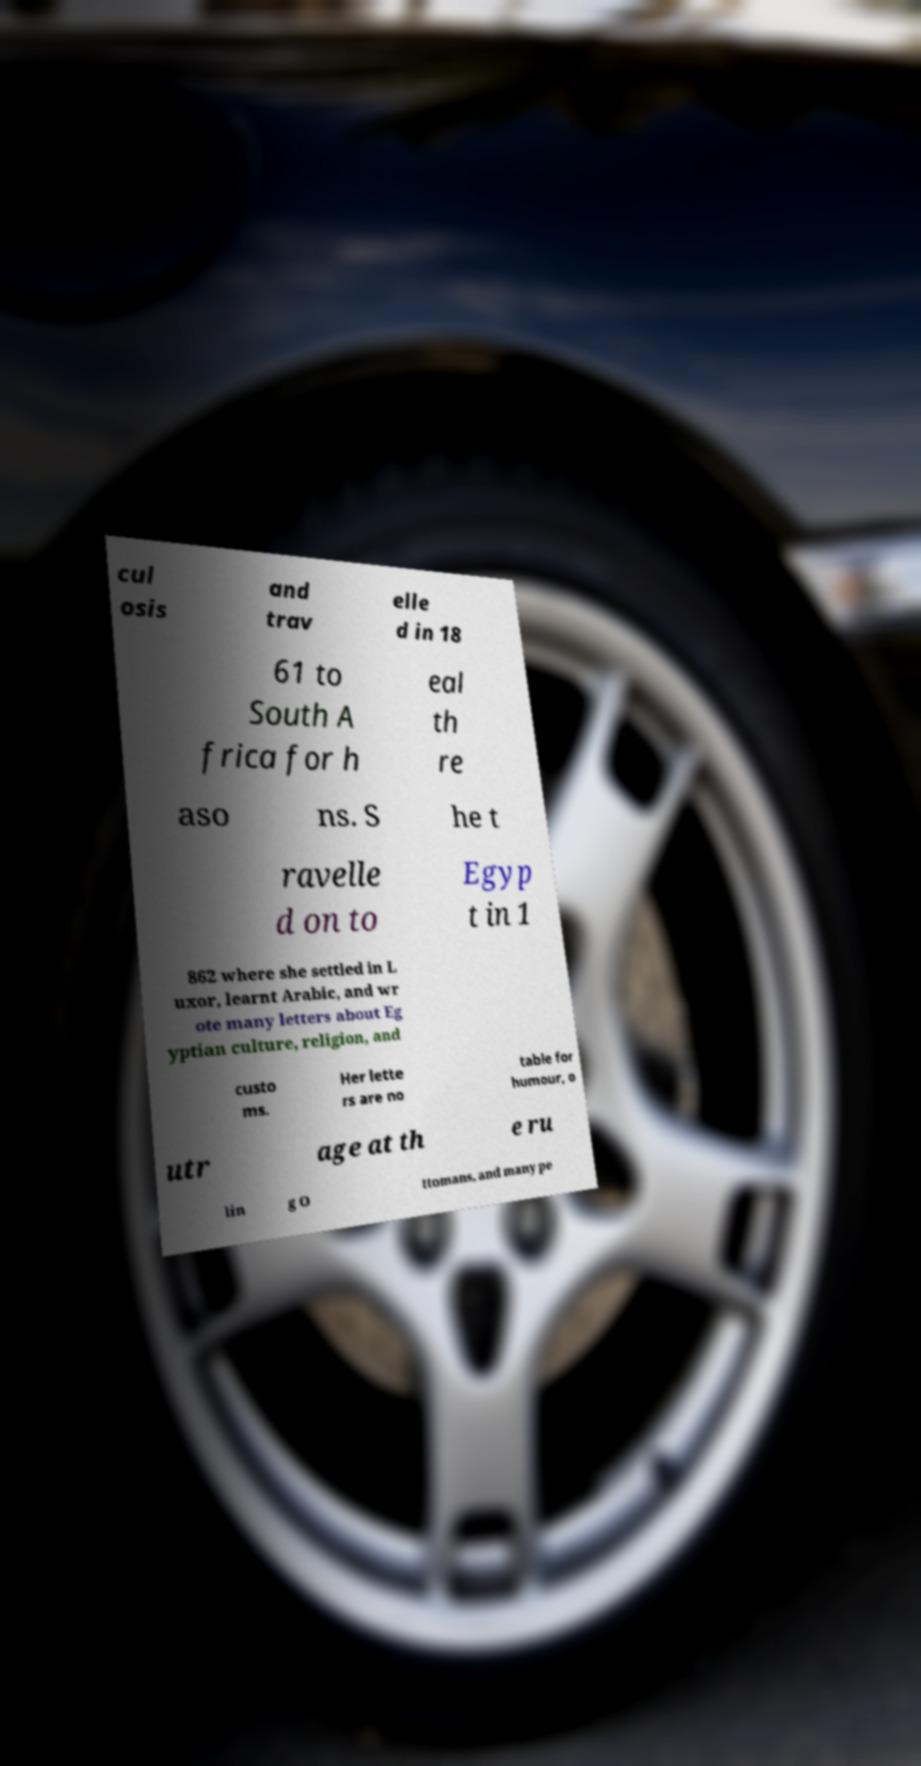There's text embedded in this image that I need extracted. Can you transcribe it verbatim? cul osis and trav elle d in 18 61 to South A frica for h eal th re aso ns. S he t ravelle d on to Egyp t in 1 862 where she settled in L uxor, learnt Arabic, and wr ote many letters about Eg yptian culture, religion, and custo ms. Her lette rs are no table for humour, o utr age at th e ru lin g O ttomans, and many pe 